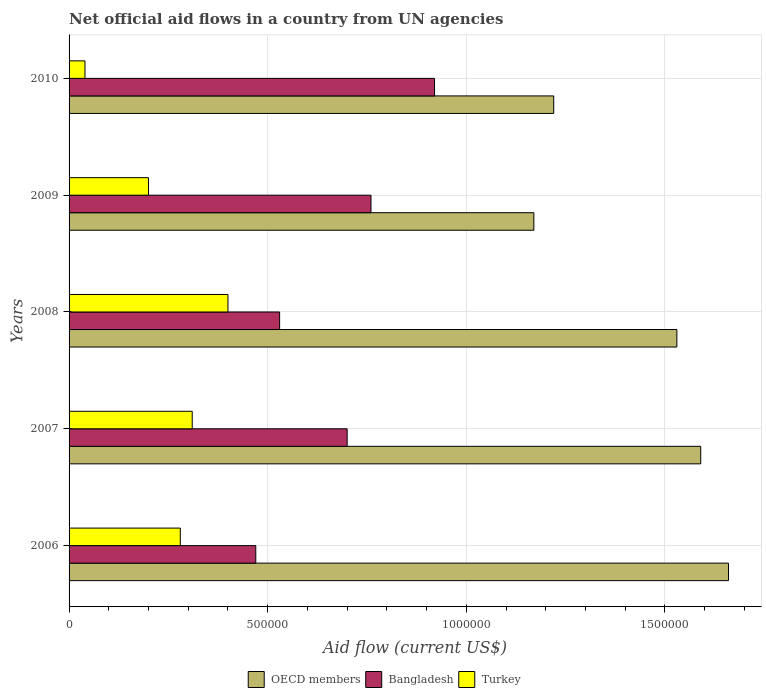Are the number of bars on each tick of the Y-axis equal?
Your answer should be compact. Yes. How many bars are there on the 1st tick from the bottom?
Make the answer very short. 3. What is the label of the 4th group of bars from the top?
Your answer should be compact. 2007. In how many cases, is the number of bars for a given year not equal to the number of legend labels?
Give a very brief answer. 0. What is the net official aid flow in Bangladesh in 2009?
Offer a terse response. 7.60e+05. Across all years, what is the maximum net official aid flow in Bangladesh?
Provide a succinct answer. 9.20e+05. Across all years, what is the minimum net official aid flow in Bangladesh?
Your answer should be very brief. 4.70e+05. In which year was the net official aid flow in Bangladesh minimum?
Give a very brief answer. 2006. What is the total net official aid flow in Turkey in the graph?
Your answer should be compact. 1.23e+06. What is the difference between the net official aid flow in Bangladesh in 2007 and that in 2009?
Your answer should be very brief. -6.00e+04. What is the average net official aid flow in Turkey per year?
Keep it short and to the point. 2.46e+05. In the year 2008, what is the difference between the net official aid flow in Bangladesh and net official aid flow in Turkey?
Ensure brevity in your answer.  1.30e+05. What is the ratio of the net official aid flow in Bangladesh in 2006 to that in 2009?
Make the answer very short. 0.62. What is the difference between the highest and the lowest net official aid flow in OECD members?
Offer a very short reply. 4.90e+05. In how many years, is the net official aid flow in Bangladesh greater than the average net official aid flow in Bangladesh taken over all years?
Offer a very short reply. 3. Is the sum of the net official aid flow in OECD members in 2008 and 2010 greater than the maximum net official aid flow in Bangladesh across all years?
Make the answer very short. Yes. Is it the case that in every year, the sum of the net official aid flow in OECD members and net official aid flow in Turkey is greater than the net official aid flow in Bangladesh?
Ensure brevity in your answer.  Yes. Are all the bars in the graph horizontal?
Ensure brevity in your answer.  Yes. Are the values on the major ticks of X-axis written in scientific E-notation?
Provide a short and direct response. No. Where does the legend appear in the graph?
Your answer should be very brief. Bottom center. How many legend labels are there?
Ensure brevity in your answer.  3. What is the title of the graph?
Provide a succinct answer. Net official aid flows in a country from UN agencies. Does "West Bank and Gaza" appear as one of the legend labels in the graph?
Provide a succinct answer. No. What is the label or title of the X-axis?
Provide a short and direct response. Aid flow (current US$). What is the label or title of the Y-axis?
Give a very brief answer. Years. What is the Aid flow (current US$) in OECD members in 2006?
Offer a very short reply. 1.66e+06. What is the Aid flow (current US$) of Turkey in 2006?
Keep it short and to the point. 2.80e+05. What is the Aid flow (current US$) in OECD members in 2007?
Offer a terse response. 1.59e+06. What is the Aid flow (current US$) in OECD members in 2008?
Keep it short and to the point. 1.53e+06. What is the Aid flow (current US$) in Bangladesh in 2008?
Keep it short and to the point. 5.30e+05. What is the Aid flow (current US$) in Turkey in 2008?
Provide a succinct answer. 4.00e+05. What is the Aid flow (current US$) of OECD members in 2009?
Give a very brief answer. 1.17e+06. What is the Aid flow (current US$) in Bangladesh in 2009?
Your response must be concise. 7.60e+05. What is the Aid flow (current US$) of OECD members in 2010?
Your answer should be very brief. 1.22e+06. What is the Aid flow (current US$) in Bangladesh in 2010?
Provide a succinct answer. 9.20e+05. Across all years, what is the maximum Aid flow (current US$) of OECD members?
Keep it short and to the point. 1.66e+06. Across all years, what is the maximum Aid flow (current US$) in Bangladesh?
Give a very brief answer. 9.20e+05. Across all years, what is the minimum Aid flow (current US$) in OECD members?
Your answer should be compact. 1.17e+06. Across all years, what is the minimum Aid flow (current US$) of Bangladesh?
Your answer should be compact. 4.70e+05. Across all years, what is the minimum Aid flow (current US$) in Turkey?
Offer a terse response. 4.00e+04. What is the total Aid flow (current US$) in OECD members in the graph?
Your answer should be compact. 7.17e+06. What is the total Aid flow (current US$) in Bangladesh in the graph?
Make the answer very short. 3.38e+06. What is the total Aid flow (current US$) in Turkey in the graph?
Keep it short and to the point. 1.23e+06. What is the difference between the Aid flow (current US$) of OECD members in 2006 and that in 2007?
Your answer should be compact. 7.00e+04. What is the difference between the Aid flow (current US$) of Bangladesh in 2006 and that in 2007?
Give a very brief answer. -2.30e+05. What is the difference between the Aid flow (current US$) in OECD members in 2006 and that in 2008?
Make the answer very short. 1.30e+05. What is the difference between the Aid flow (current US$) of Bangladesh in 2006 and that in 2008?
Give a very brief answer. -6.00e+04. What is the difference between the Aid flow (current US$) in Turkey in 2006 and that in 2008?
Make the answer very short. -1.20e+05. What is the difference between the Aid flow (current US$) of OECD members in 2006 and that in 2009?
Provide a short and direct response. 4.90e+05. What is the difference between the Aid flow (current US$) of Turkey in 2006 and that in 2009?
Offer a terse response. 8.00e+04. What is the difference between the Aid flow (current US$) in Bangladesh in 2006 and that in 2010?
Your answer should be compact. -4.50e+05. What is the difference between the Aid flow (current US$) of Turkey in 2006 and that in 2010?
Your answer should be very brief. 2.40e+05. What is the difference between the Aid flow (current US$) in OECD members in 2007 and that in 2008?
Ensure brevity in your answer.  6.00e+04. What is the difference between the Aid flow (current US$) of Turkey in 2007 and that in 2008?
Offer a very short reply. -9.00e+04. What is the difference between the Aid flow (current US$) in Turkey in 2007 and that in 2009?
Keep it short and to the point. 1.10e+05. What is the difference between the Aid flow (current US$) of OECD members in 2007 and that in 2010?
Provide a short and direct response. 3.70e+05. What is the difference between the Aid flow (current US$) in OECD members in 2008 and that in 2009?
Make the answer very short. 3.60e+05. What is the difference between the Aid flow (current US$) in Turkey in 2008 and that in 2009?
Keep it short and to the point. 2.00e+05. What is the difference between the Aid flow (current US$) of OECD members in 2008 and that in 2010?
Your answer should be compact. 3.10e+05. What is the difference between the Aid flow (current US$) of Bangladesh in 2008 and that in 2010?
Provide a succinct answer. -3.90e+05. What is the difference between the Aid flow (current US$) in OECD members in 2009 and that in 2010?
Give a very brief answer. -5.00e+04. What is the difference between the Aid flow (current US$) in Bangladesh in 2009 and that in 2010?
Make the answer very short. -1.60e+05. What is the difference between the Aid flow (current US$) of Turkey in 2009 and that in 2010?
Offer a very short reply. 1.60e+05. What is the difference between the Aid flow (current US$) in OECD members in 2006 and the Aid flow (current US$) in Bangladesh in 2007?
Your answer should be compact. 9.60e+05. What is the difference between the Aid flow (current US$) of OECD members in 2006 and the Aid flow (current US$) of Turkey in 2007?
Give a very brief answer. 1.35e+06. What is the difference between the Aid flow (current US$) of OECD members in 2006 and the Aid flow (current US$) of Bangladesh in 2008?
Your response must be concise. 1.13e+06. What is the difference between the Aid flow (current US$) of OECD members in 2006 and the Aid flow (current US$) of Turkey in 2008?
Offer a very short reply. 1.26e+06. What is the difference between the Aid flow (current US$) of OECD members in 2006 and the Aid flow (current US$) of Bangladesh in 2009?
Keep it short and to the point. 9.00e+05. What is the difference between the Aid flow (current US$) in OECD members in 2006 and the Aid flow (current US$) in Turkey in 2009?
Provide a succinct answer. 1.46e+06. What is the difference between the Aid flow (current US$) of OECD members in 2006 and the Aid flow (current US$) of Bangladesh in 2010?
Your answer should be very brief. 7.40e+05. What is the difference between the Aid flow (current US$) in OECD members in 2006 and the Aid flow (current US$) in Turkey in 2010?
Offer a terse response. 1.62e+06. What is the difference between the Aid flow (current US$) in Bangladesh in 2006 and the Aid flow (current US$) in Turkey in 2010?
Your answer should be very brief. 4.30e+05. What is the difference between the Aid flow (current US$) in OECD members in 2007 and the Aid flow (current US$) in Bangladesh in 2008?
Offer a terse response. 1.06e+06. What is the difference between the Aid flow (current US$) of OECD members in 2007 and the Aid flow (current US$) of Turkey in 2008?
Your answer should be compact. 1.19e+06. What is the difference between the Aid flow (current US$) of OECD members in 2007 and the Aid flow (current US$) of Bangladesh in 2009?
Provide a succinct answer. 8.30e+05. What is the difference between the Aid flow (current US$) of OECD members in 2007 and the Aid flow (current US$) of Turkey in 2009?
Offer a very short reply. 1.39e+06. What is the difference between the Aid flow (current US$) in OECD members in 2007 and the Aid flow (current US$) in Bangladesh in 2010?
Make the answer very short. 6.70e+05. What is the difference between the Aid flow (current US$) of OECD members in 2007 and the Aid flow (current US$) of Turkey in 2010?
Offer a very short reply. 1.55e+06. What is the difference between the Aid flow (current US$) of OECD members in 2008 and the Aid flow (current US$) of Bangladesh in 2009?
Your answer should be compact. 7.70e+05. What is the difference between the Aid flow (current US$) of OECD members in 2008 and the Aid flow (current US$) of Turkey in 2009?
Offer a very short reply. 1.33e+06. What is the difference between the Aid flow (current US$) of Bangladesh in 2008 and the Aid flow (current US$) of Turkey in 2009?
Your answer should be very brief. 3.30e+05. What is the difference between the Aid flow (current US$) of OECD members in 2008 and the Aid flow (current US$) of Bangladesh in 2010?
Provide a short and direct response. 6.10e+05. What is the difference between the Aid flow (current US$) in OECD members in 2008 and the Aid flow (current US$) in Turkey in 2010?
Provide a succinct answer. 1.49e+06. What is the difference between the Aid flow (current US$) of Bangladesh in 2008 and the Aid flow (current US$) of Turkey in 2010?
Give a very brief answer. 4.90e+05. What is the difference between the Aid flow (current US$) in OECD members in 2009 and the Aid flow (current US$) in Bangladesh in 2010?
Provide a succinct answer. 2.50e+05. What is the difference between the Aid flow (current US$) in OECD members in 2009 and the Aid flow (current US$) in Turkey in 2010?
Offer a very short reply. 1.13e+06. What is the difference between the Aid flow (current US$) of Bangladesh in 2009 and the Aid flow (current US$) of Turkey in 2010?
Make the answer very short. 7.20e+05. What is the average Aid flow (current US$) in OECD members per year?
Ensure brevity in your answer.  1.43e+06. What is the average Aid flow (current US$) of Bangladesh per year?
Give a very brief answer. 6.76e+05. What is the average Aid flow (current US$) in Turkey per year?
Offer a very short reply. 2.46e+05. In the year 2006, what is the difference between the Aid flow (current US$) of OECD members and Aid flow (current US$) of Bangladesh?
Your response must be concise. 1.19e+06. In the year 2006, what is the difference between the Aid flow (current US$) in OECD members and Aid flow (current US$) in Turkey?
Offer a terse response. 1.38e+06. In the year 2006, what is the difference between the Aid flow (current US$) in Bangladesh and Aid flow (current US$) in Turkey?
Your answer should be very brief. 1.90e+05. In the year 2007, what is the difference between the Aid flow (current US$) of OECD members and Aid flow (current US$) of Bangladesh?
Your answer should be compact. 8.90e+05. In the year 2007, what is the difference between the Aid flow (current US$) of OECD members and Aid flow (current US$) of Turkey?
Offer a very short reply. 1.28e+06. In the year 2008, what is the difference between the Aid flow (current US$) in OECD members and Aid flow (current US$) in Turkey?
Provide a short and direct response. 1.13e+06. In the year 2008, what is the difference between the Aid flow (current US$) of Bangladesh and Aid flow (current US$) of Turkey?
Your answer should be compact. 1.30e+05. In the year 2009, what is the difference between the Aid flow (current US$) in OECD members and Aid flow (current US$) in Bangladesh?
Provide a succinct answer. 4.10e+05. In the year 2009, what is the difference between the Aid flow (current US$) of OECD members and Aid flow (current US$) of Turkey?
Make the answer very short. 9.70e+05. In the year 2009, what is the difference between the Aid flow (current US$) in Bangladesh and Aid flow (current US$) in Turkey?
Offer a very short reply. 5.60e+05. In the year 2010, what is the difference between the Aid flow (current US$) in OECD members and Aid flow (current US$) in Turkey?
Offer a terse response. 1.18e+06. In the year 2010, what is the difference between the Aid flow (current US$) of Bangladesh and Aid flow (current US$) of Turkey?
Make the answer very short. 8.80e+05. What is the ratio of the Aid flow (current US$) in OECD members in 2006 to that in 2007?
Your response must be concise. 1.04. What is the ratio of the Aid flow (current US$) of Bangladesh in 2006 to that in 2007?
Keep it short and to the point. 0.67. What is the ratio of the Aid flow (current US$) of Turkey in 2006 to that in 2007?
Keep it short and to the point. 0.9. What is the ratio of the Aid flow (current US$) of OECD members in 2006 to that in 2008?
Ensure brevity in your answer.  1.08. What is the ratio of the Aid flow (current US$) of Bangladesh in 2006 to that in 2008?
Keep it short and to the point. 0.89. What is the ratio of the Aid flow (current US$) in OECD members in 2006 to that in 2009?
Provide a succinct answer. 1.42. What is the ratio of the Aid flow (current US$) in Bangladesh in 2006 to that in 2009?
Give a very brief answer. 0.62. What is the ratio of the Aid flow (current US$) of Turkey in 2006 to that in 2009?
Provide a succinct answer. 1.4. What is the ratio of the Aid flow (current US$) in OECD members in 2006 to that in 2010?
Give a very brief answer. 1.36. What is the ratio of the Aid flow (current US$) in Bangladesh in 2006 to that in 2010?
Make the answer very short. 0.51. What is the ratio of the Aid flow (current US$) of Turkey in 2006 to that in 2010?
Your answer should be very brief. 7. What is the ratio of the Aid flow (current US$) in OECD members in 2007 to that in 2008?
Your answer should be very brief. 1.04. What is the ratio of the Aid flow (current US$) of Bangladesh in 2007 to that in 2008?
Provide a succinct answer. 1.32. What is the ratio of the Aid flow (current US$) in Turkey in 2007 to that in 2008?
Offer a terse response. 0.78. What is the ratio of the Aid flow (current US$) of OECD members in 2007 to that in 2009?
Give a very brief answer. 1.36. What is the ratio of the Aid flow (current US$) in Bangladesh in 2007 to that in 2009?
Give a very brief answer. 0.92. What is the ratio of the Aid flow (current US$) of Turkey in 2007 to that in 2009?
Ensure brevity in your answer.  1.55. What is the ratio of the Aid flow (current US$) in OECD members in 2007 to that in 2010?
Offer a terse response. 1.3. What is the ratio of the Aid flow (current US$) in Bangladesh in 2007 to that in 2010?
Keep it short and to the point. 0.76. What is the ratio of the Aid flow (current US$) in Turkey in 2007 to that in 2010?
Provide a succinct answer. 7.75. What is the ratio of the Aid flow (current US$) in OECD members in 2008 to that in 2009?
Provide a succinct answer. 1.31. What is the ratio of the Aid flow (current US$) in Bangladesh in 2008 to that in 2009?
Provide a succinct answer. 0.7. What is the ratio of the Aid flow (current US$) of Turkey in 2008 to that in 2009?
Keep it short and to the point. 2. What is the ratio of the Aid flow (current US$) of OECD members in 2008 to that in 2010?
Your answer should be compact. 1.25. What is the ratio of the Aid flow (current US$) in Bangladesh in 2008 to that in 2010?
Provide a succinct answer. 0.58. What is the ratio of the Aid flow (current US$) in Turkey in 2008 to that in 2010?
Give a very brief answer. 10. What is the ratio of the Aid flow (current US$) in Bangladesh in 2009 to that in 2010?
Your answer should be very brief. 0.83. What is the ratio of the Aid flow (current US$) in Turkey in 2009 to that in 2010?
Offer a terse response. 5. What is the difference between the highest and the second highest Aid flow (current US$) of OECD members?
Provide a succinct answer. 7.00e+04. What is the difference between the highest and the second highest Aid flow (current US$) in Bangladesh?
Give a very brief answer. 1.60e+05. What is the difference between the highest and the lowest Aid flow (current US$) of OECD members?
Provide a succinct answer. 4.90e+05. What is the difference between the highest and the lowest Aid flow (current US$) of Bangladesh?
Your response must be concise. 4.50e+05. 